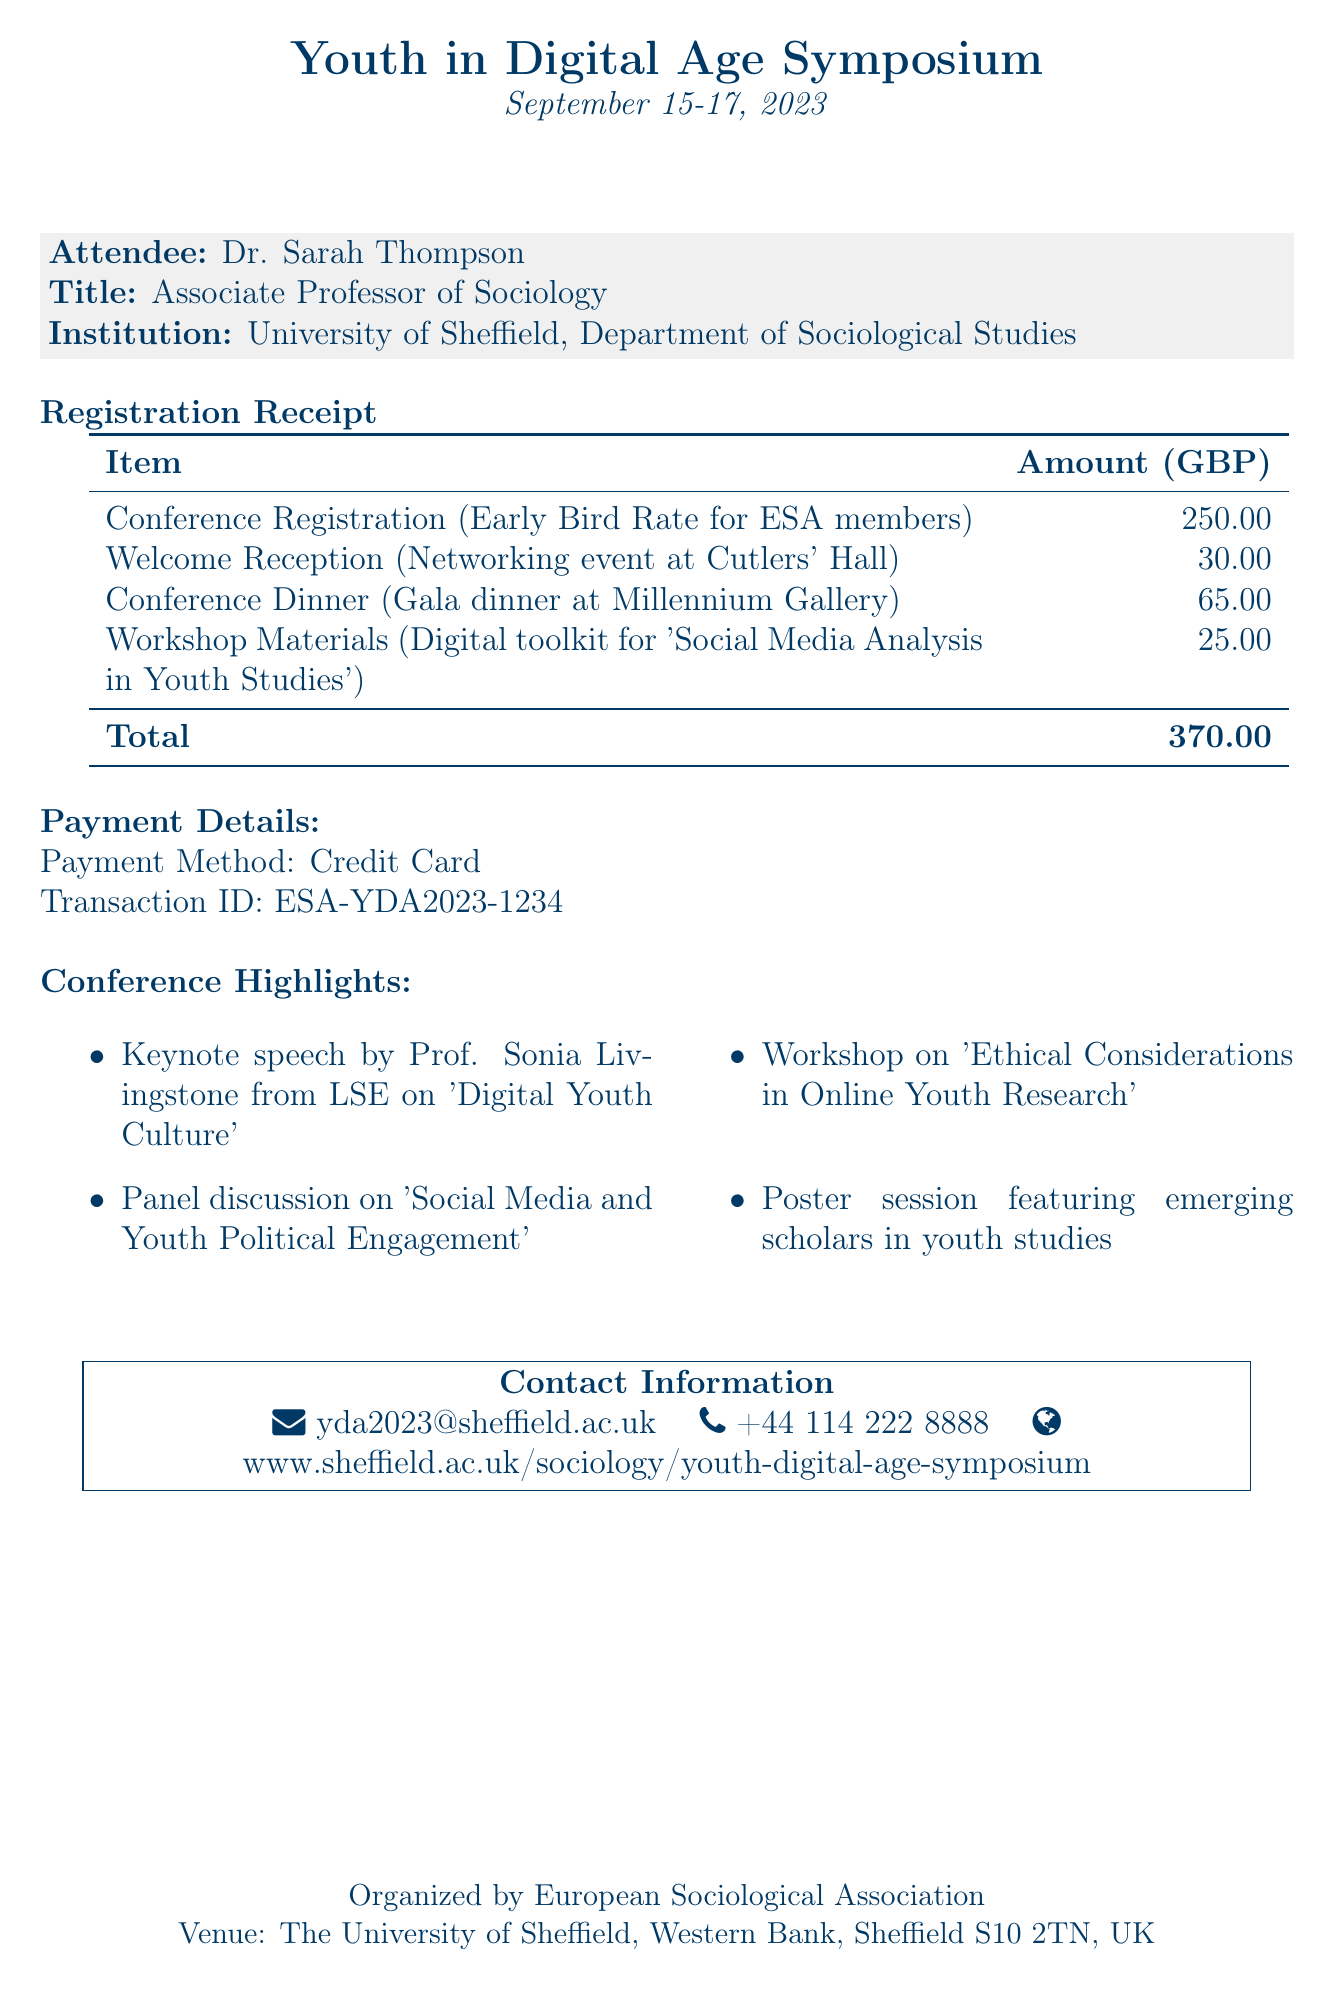What is the name of the conference? The name of the conference is specified at the top of the document.
Answer: Youth in Digital Age Symposium Who is the organizer of the symposium? The organizer is listed prominently within the document, indicating the entity responsible for the event.
Answer: European Sociological Association What is the total amount paid for registration and costs? The total amount is provided in the payment details section, summing up the individual itemized costs.
Answer: 370 When does the conference take place? The dates of the conference are clearly stated in the document, marking the event's timeline.
Answer: September 15-17, 2023 What payment method was used? The payment method is specified in the payment details section of the receipt.
Answer: Credit Card Which venue is hosting the symposium? The venue is mentioned in the footer of the document, providing location information for attendees.
Answer: The University of Sheffield, Western Bank, Sheffield S10 2TN, UK What is one of the keynote speech topics? The document lists specific highlights of the conference, including the keynote speech topic.
Answer: Digital Youth Culture How much is the early bird registration fee? The registration fee is itemized in the document, specifically for the early bird rate.
Answer: 250 What item is associated with a cost of 30? The itemized costs section indicates specific events and their associated fees.
Answer: Welcome Reception 